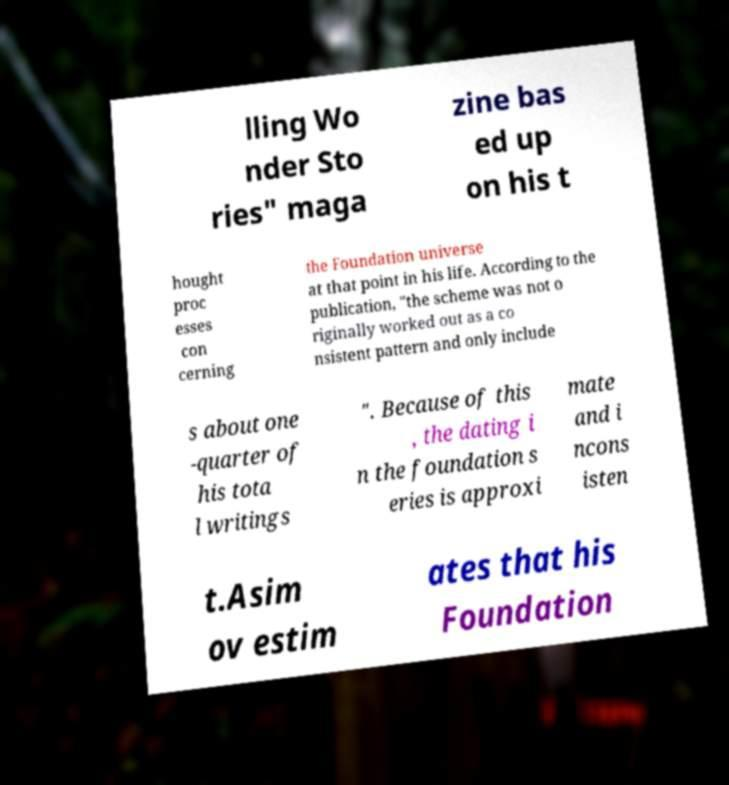There's text embedded in this image that I need extracted. Can you transcribe it verbatim? lling Wo nder Sto ries" maga zine bas ed up on his t hought proc esses con cerning the Foundation universe at that point in his life. According to the publication, "the scheme was not o riginally worked out as a co nsistent pattern and only include s about one -quarter of his tota l writings ". Because of this , the dating i n the foundation s eries is approxi mate and i ncons isten t.Asim ov estim ates that his Foundation 